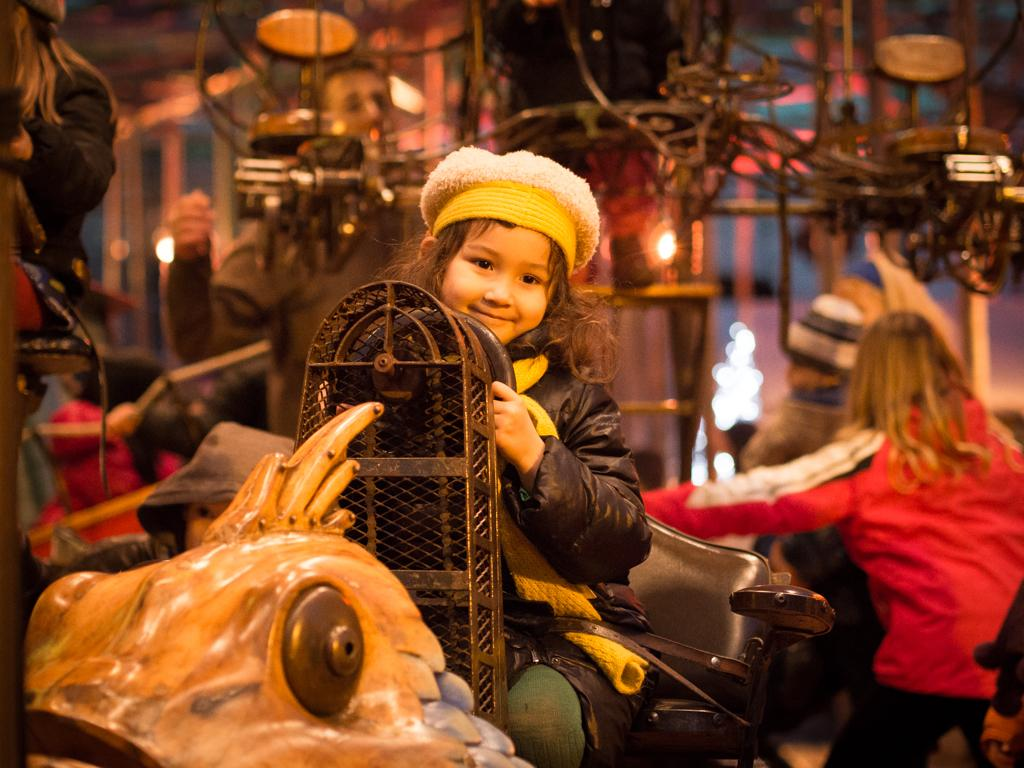What is the main subject of the image? The main subject of the image is an amusement ride. What are the kids doing in the image? The kids are riding on the amusement ride. Can you describe the person in the image? There is a person in the image, but their specific role or action is not clear from the provided facts. What is the weight of the attraction in the image? The provided facts do not mention the weight of the amusement ride or any attraction, so it cannot be determined from the image. 